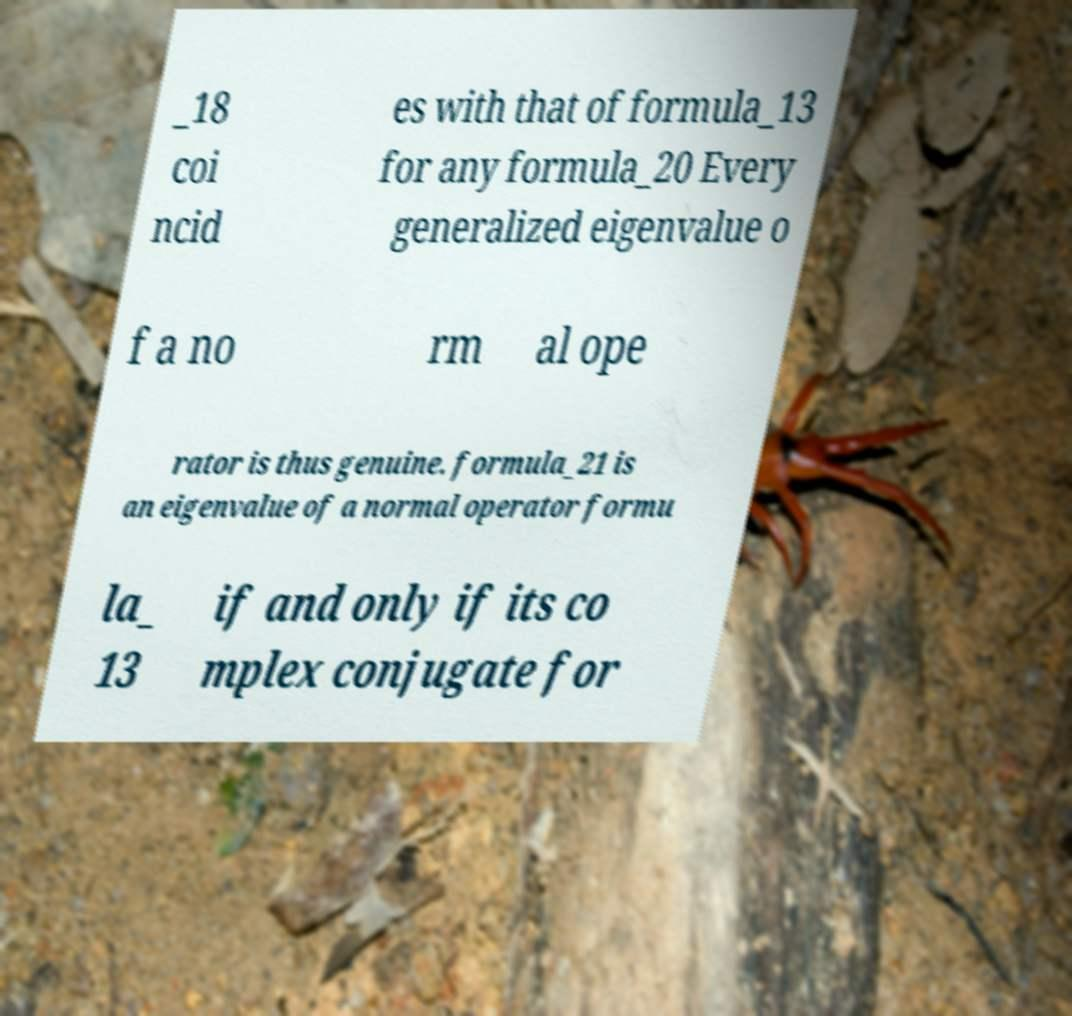I need the written content from this picture converted into text. Can you do that? _18 coi ncid es with that of formula_13 for any formula_20 Every generalized eigenvalue o f a no rm al ope rator is thus genuine. formula_21 is an eigenvalue of a normal operator formu la_ 13 if and only if its co mplex conjugate for 